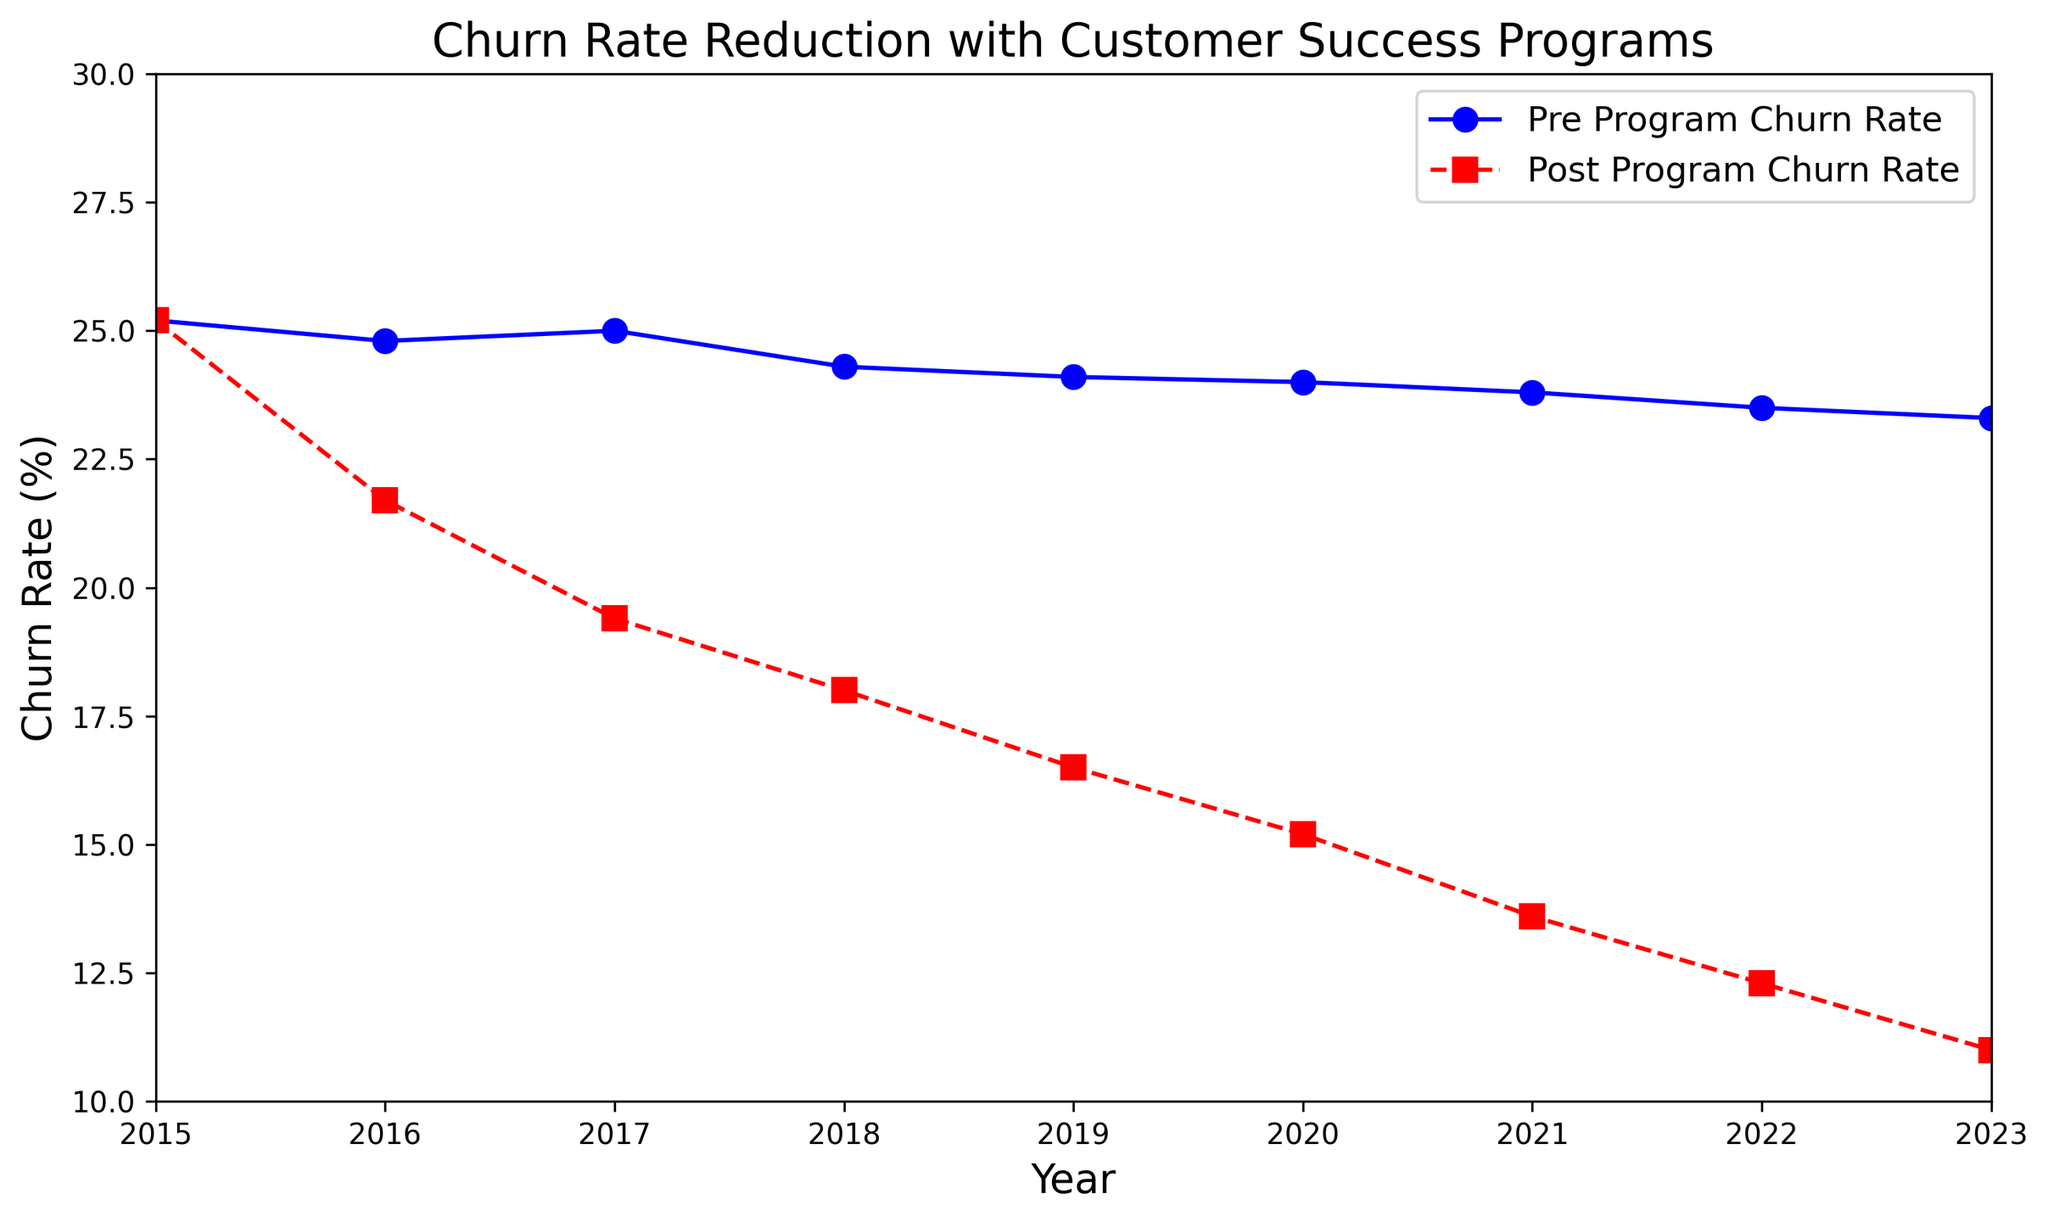What's the trend of the Pre Customer Success Program Churn Rate from 2015 to 2023? The Pre Customer Success Program Churn Rate shows a slight decreasing trend from 25.2% in 2015 to 23.3% in 2023. To determine this, observe the blue line with circular markers which shows a gradual decline over the years.
Answer: Decreasing trend In which year did the Post Customer Success Program Churn Rate drop below 20%? According to the red line with square markers, the Post Customer Success Program Churn Rate dropped below 20% in the year 2017. It was 19.4% in that year.
Answer: 2017 How much did the Post Customer Success Program Churn Rate decrease from 2015 to 2023? The Post Customer Success Program Churn Rate decreased from 25.2% in 2015 to 11.0% in 2023. First, note the churn rates for these years on the red line. Subtract 11.0 from 25.2 to find the decrease.
Answer: 14.2% Is the Post Customer Success Program Churn Rate ever higher than the Pre Customer Success Program Churn Rate in any year? No, the Post Customer Success Program Churn Rate is consistently lower than the Pre Customer Success Program Churn Rate in all years displayed. The red line is always below the blue line across the entire period from 2015 to 2023.
Answer: No What is the average Post Customer Success Program Churn Rate from 2016 to 2020? To find the average Post Customer Success Program Churn Rate from 2016 to 2020: Add the churn rates of these years (21.7 + 19.4 + 18.0 + 16.5 + 15.2 = 90.8), then divide by 5.
Answer: 18.16% Between which consecutive years is the largest drop in Post Customer Success Program Churn Rate observed? The largest drop in the Post Customer Success Program Churn Rate occurs between 2016 and 2017. The rate decreased from 21.7% to 19.4%, showing a reduction of 2.3 percentage points, the largest observed between any consecutive years.
Answer: 2016 to 2017 What can you infer about the effectiveness of Customer Success Programs based on the observed churn rates post-implementation vs. pre-implementation? The Post Customer Success Program Churn Rates consistently decline year over year and are significantly lower than the Pre Customer Success Program Churn Rates. This suggests that the implementation of Customer Success Programs is effective in reducing churn rates. Observe that the red line (post-program) shows a notable decline compared to the relatively stable blue line (pre-program).
Answer: Effective in reducing churn rates How many years after implementation does it take for the Post Customer Success Program Churn Rate to be half the initial Pre Customer Success Program Churn Rate? The initial Pre Customer Success Program Churn Rate is 25.2% in 2015. Half of this value is 12.6%. The Post Customer Success Program Churn Rate drops below 12.6% in 2022 (12.3%). This occurs 7 years after the initial implementation in 2015.
Answer: 7 years 